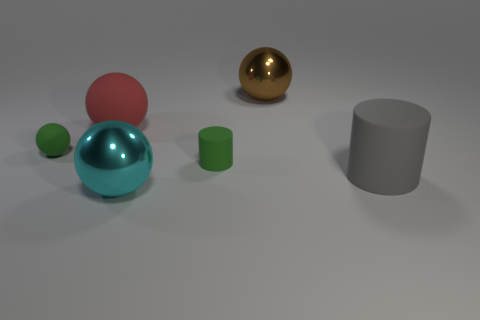How is the lighting in the image contributing to the mood? The soft, diffuse lighting creates a calm, neutral mood. It minimizes harsh shadows and allows the intrinsic colors and materials of the objects to be clearly viewed, highlighting their shapes and textures without strong emotional suggestion. 